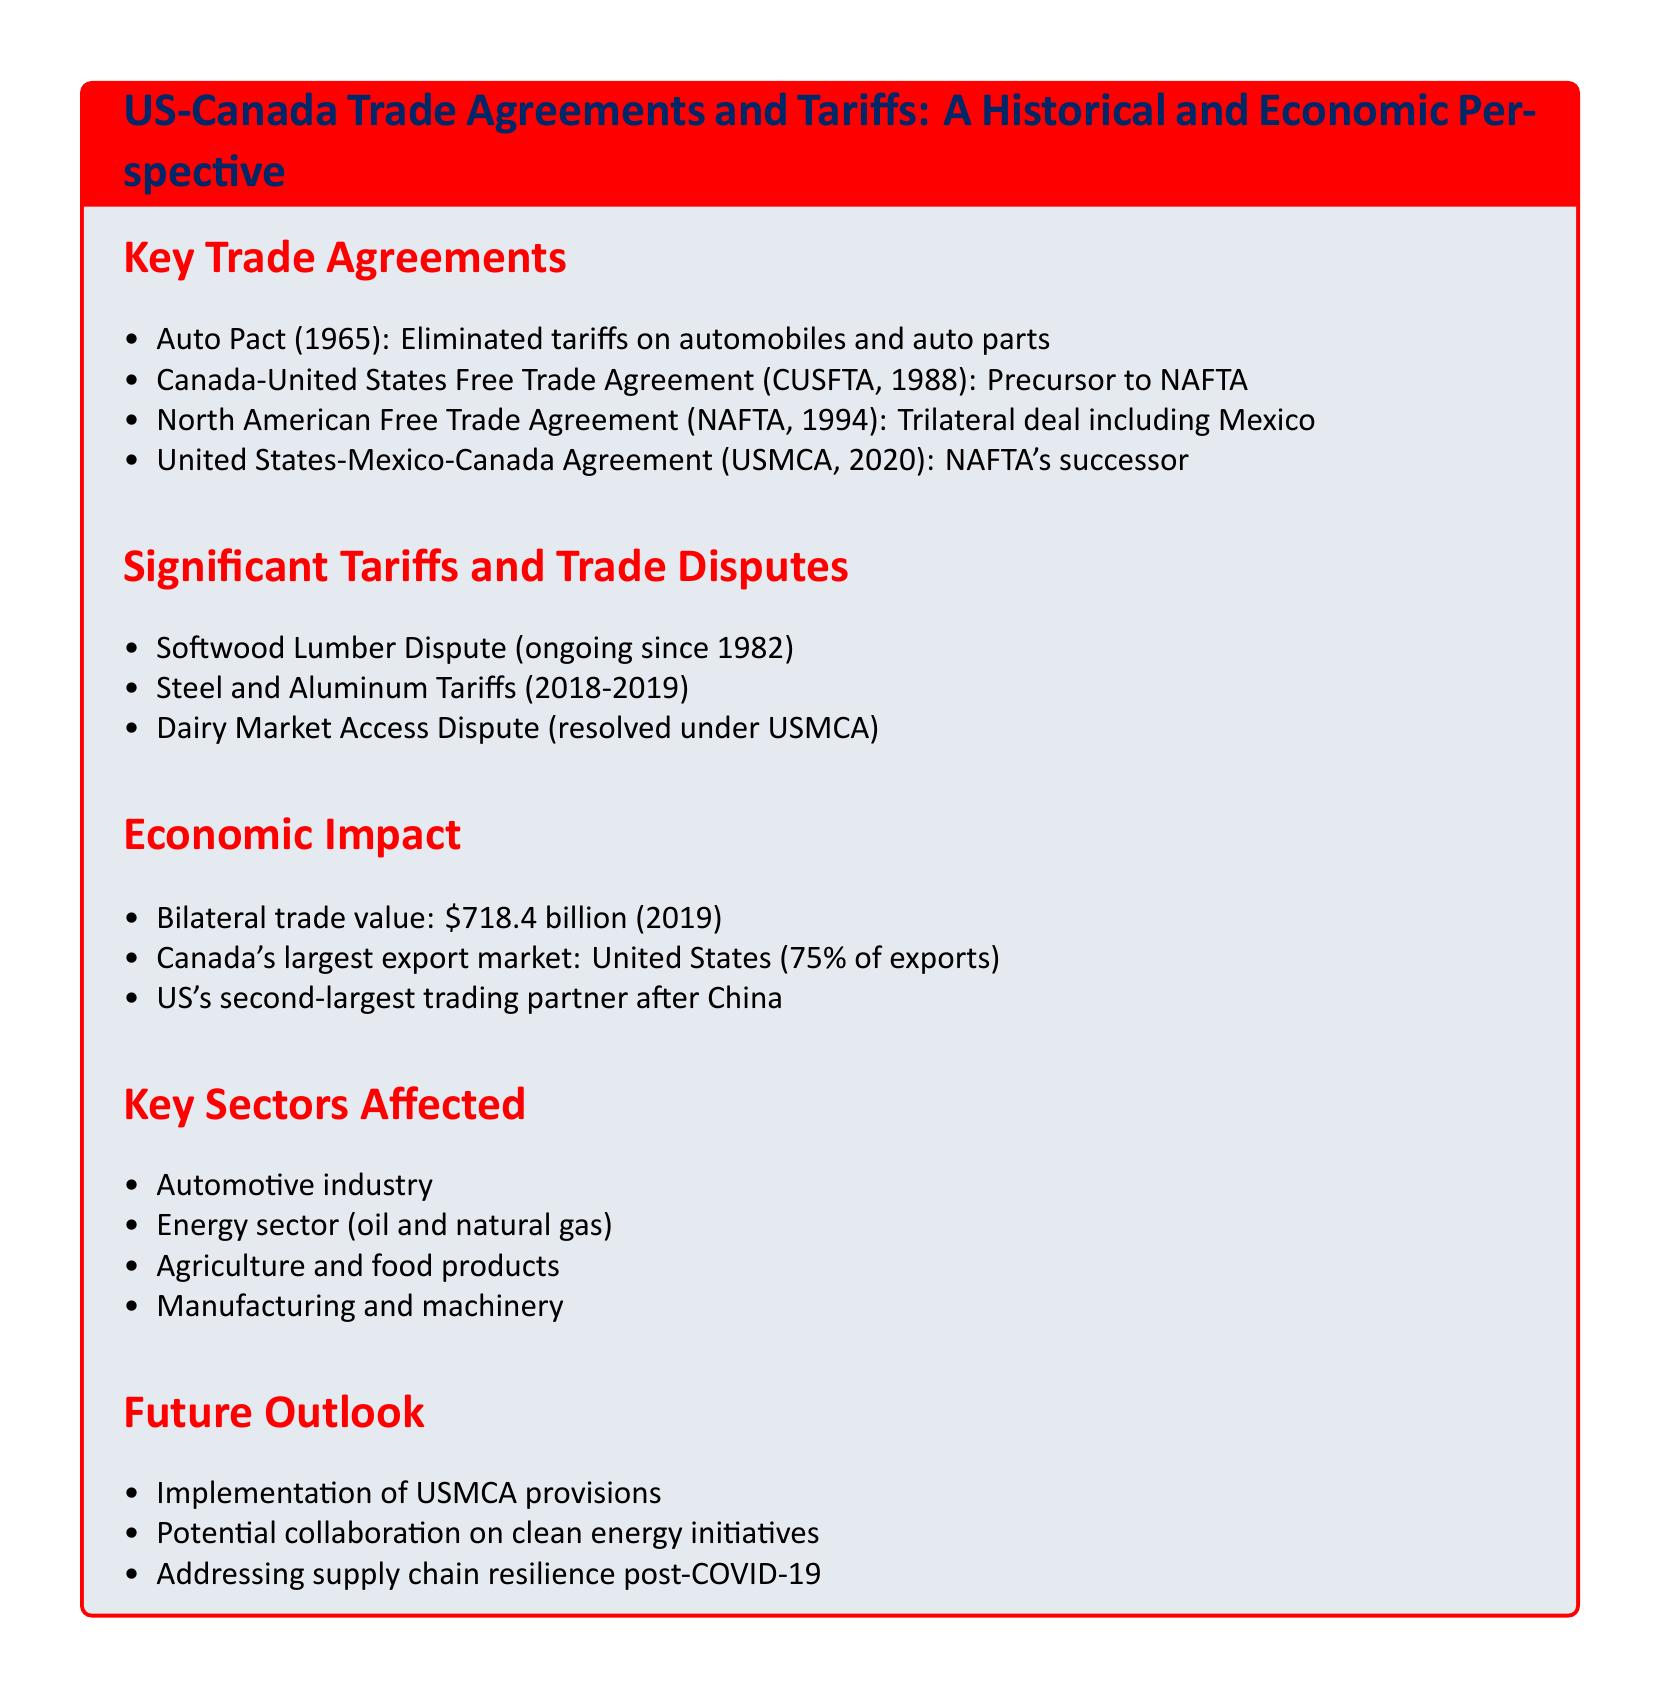What year was the Auto Pact established? The Auto Pact was established in 1965, as mentioned in the key trade agreements section.
Answer: 1965 What percentage of Canada's exports go to the United States? The document states that 75% of Canada's exports are sent to the United States.
Answer: 75% What is the value of bilateral trade between the US and Canada in 2019? The document provides the bilateral trade value as $718.4 billion in 2019.
Answer: $718.4 billion Which trade agreement is known as NAFTA's successor? The United States-Mexico-Canada Agreement (USMCA) is identified as NAFTA's successor in the key trade agreements section.
Answer: USMCA What ongoing trade dispute has been affecting US-Canada relations since 1982? The Softwood Lumber Dispute is highlighted as an ongoing trade dispute since 1982.
Answer: Softwood Lumber Dispute Which sector is listed as being affected by trade agreements? The automotive industry is mentioned as one of the key sectors affected by trade agreements.
Answer: Automotive industry What major market access dispute was resolved under USMCA? The document notes that the Dairy Market Access Dispute was resolved under USMCA.
Answer: Dairy Market Access Dispute What is a potential future collaboration area mentioned in the document? The document suggests potential collaboration on clean energy initiatives as a future outlook.
Answer: Clean energy initiatives 